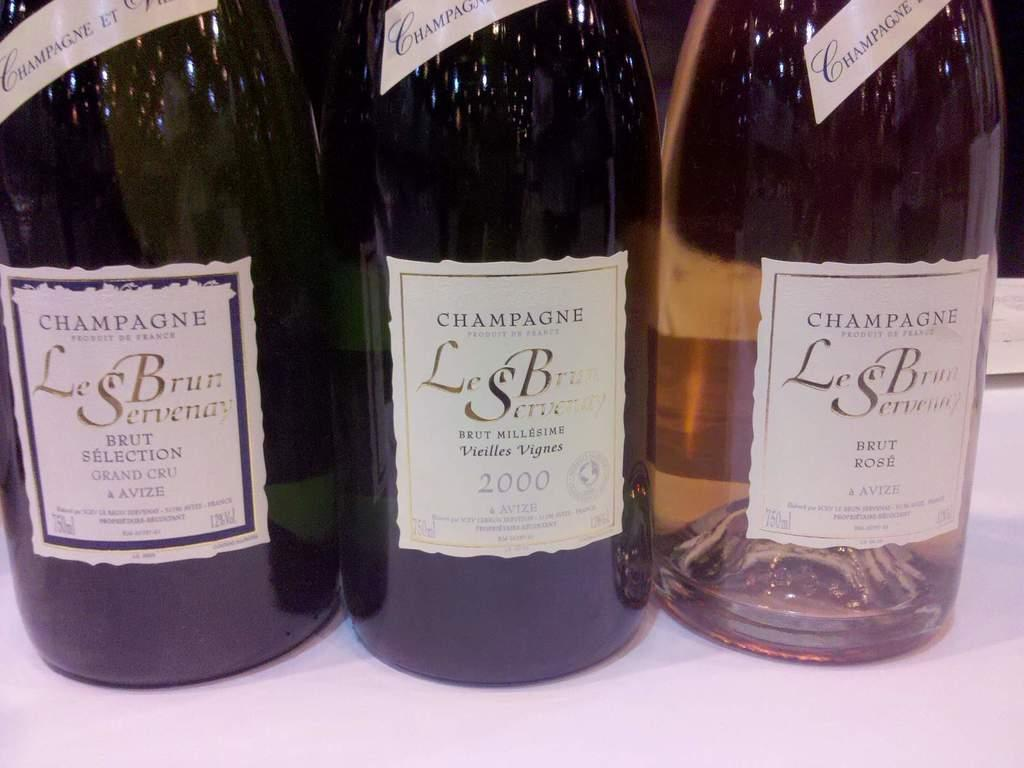<image>
Render a clear and concise summary of the photo. Three LeBrun Servenay wine bottles are on a white table cloth. 